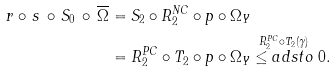Convert formula to latex. <formula><loc_0><loc_0><loc_500><loc_500>r \circ \, s \, \circ \, S _ { 0 } \, \circ \, \overline { \Omega } & = S _ { 2 } \circ R ^ { N C } _ { 2 } \circ p \circ \Omega _ { Y } \\ & = R ^ { P C } _ { 2 } \circ T _ { 2 } \circ p \circ \Omega _ { Y } \stackrel { R ^ { P C } _ { 2 } \circ T _ { 2 } ( \gamma ) } { \leq a d s t o } 0 .</formula> 